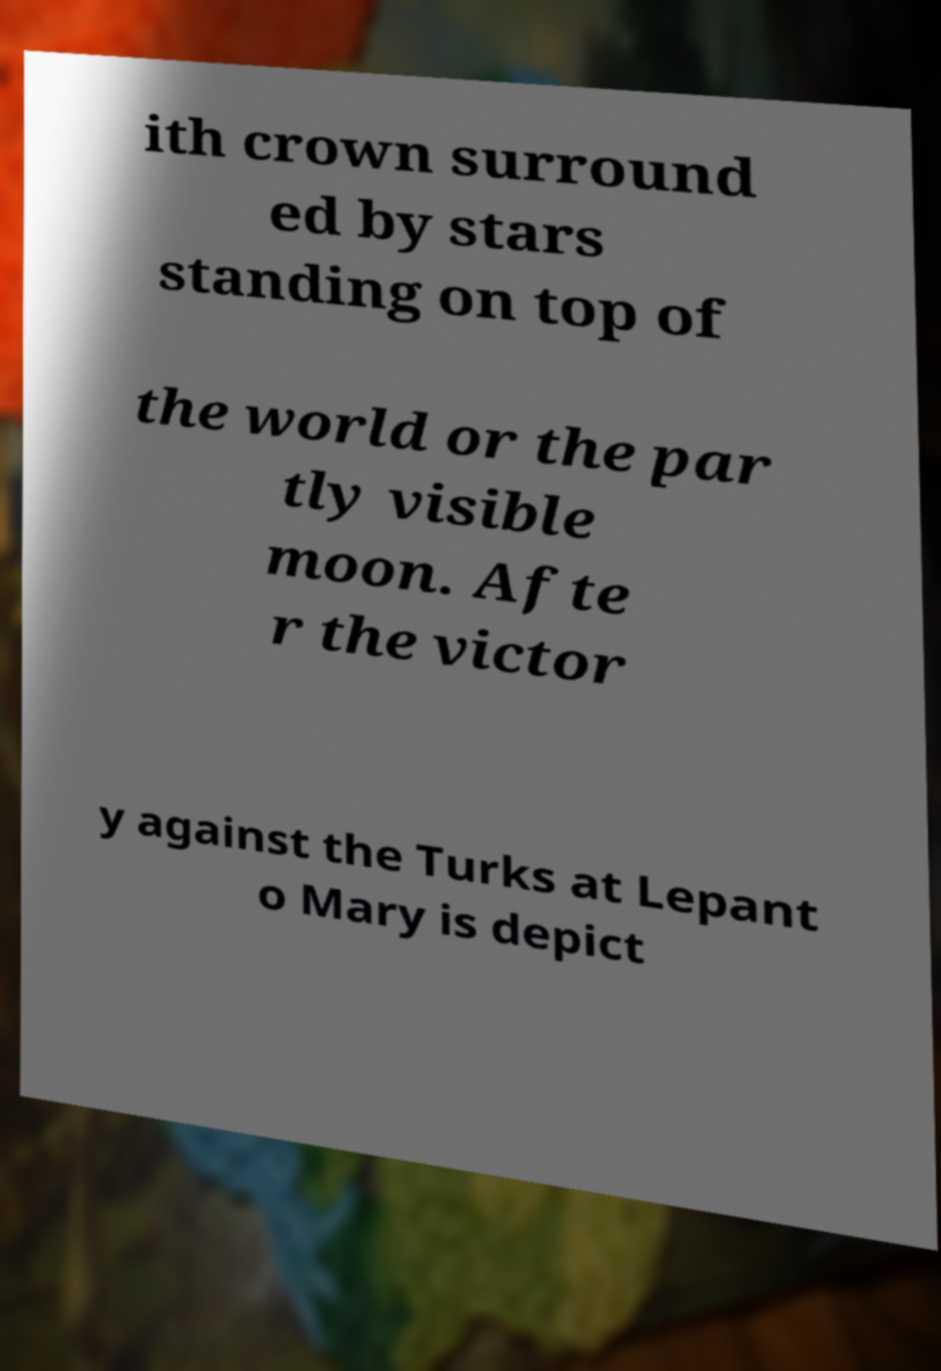Please read and relay the text visible in this image. What does it say? ith crown surround ed by stars standing on top of the world or the par tly visible moon. Afte r the victor y against the Turks at Lepant o Mary is depict 